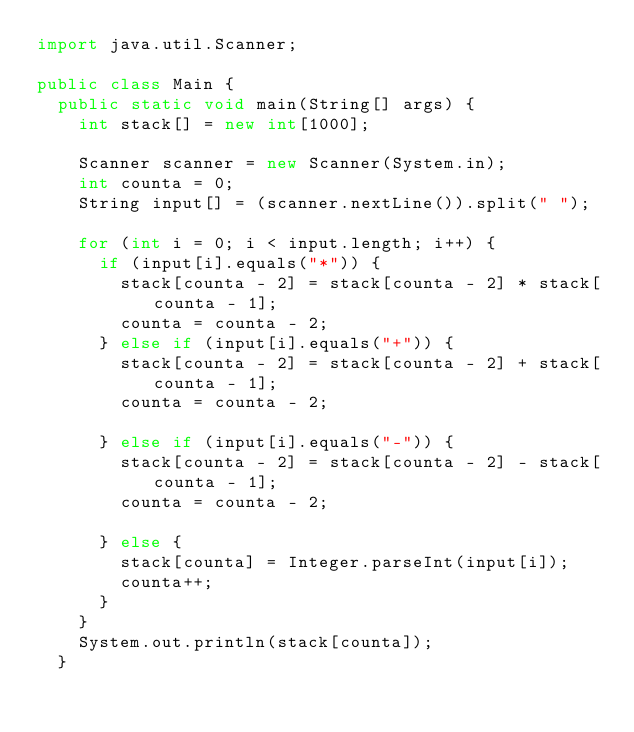Convert code to text. <code><loc_0><loc_0><loc_500><loc_500><_Java_>import java.util.Scanner;

public class Main {
	public static void main(String[] args) {
		int stack[] = new int[1000];

		Scanner scanner = new Scanner(System.in);
		int counta = 0;
		String input[] = (scanner.nextLine()).split(" ");

		for (int i = 0; i < input.length; i++) {
			if (input[i].equals("*")) {
				stack[counta - 2] = stack[counta - 2] * stack[counta - 1];
				counta = counta - 2;
			} else if (input[i].equals("+")) {
				stack[counta - 2] = stack[counta - 2] + stack[counta - 1];
				counta = counta - 2;

			} else if (input[i].equals("-")) {
				stack[counta - 2] = stack[counta - 2] - stack[counta - 1];
				counta = counta - 2;

			} else {
				stack[counta] = Integer.parseInt(input[i]);
				counta++;
			}
		}
		System.out.println(stack[counta]);
	}
</code> 